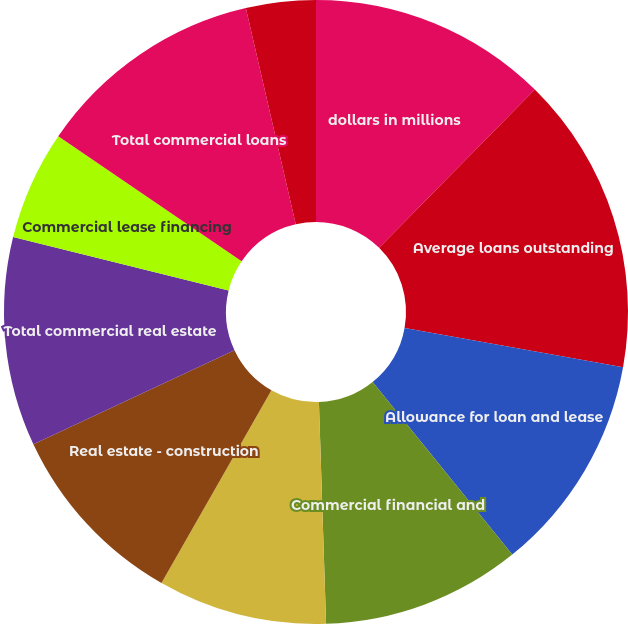<chart> <loc_0><loc_0><loc_500><loc_500><pie_chart><fcel>dollars in millions<fcel>Average loans outstanding<fcel>Allowance for loan and lease<fcel>Commercial financial and<fcel>Real estate - commercial<fcel>Real estate - construction<fcel>Total commercial real estate<fcel>Commercial lease financing<fcel>Total commercial loans<fcel>Key Community Bank<nl><fcel>12.37%<fcel>15.46%<fcel>11.34%<fcel>10.31%<fcel>8.76%<fcel>9.79%<fcel>10.82%<fcel>5.67%<fcel>11.86%<fcel>3.61%<nl></chart> 